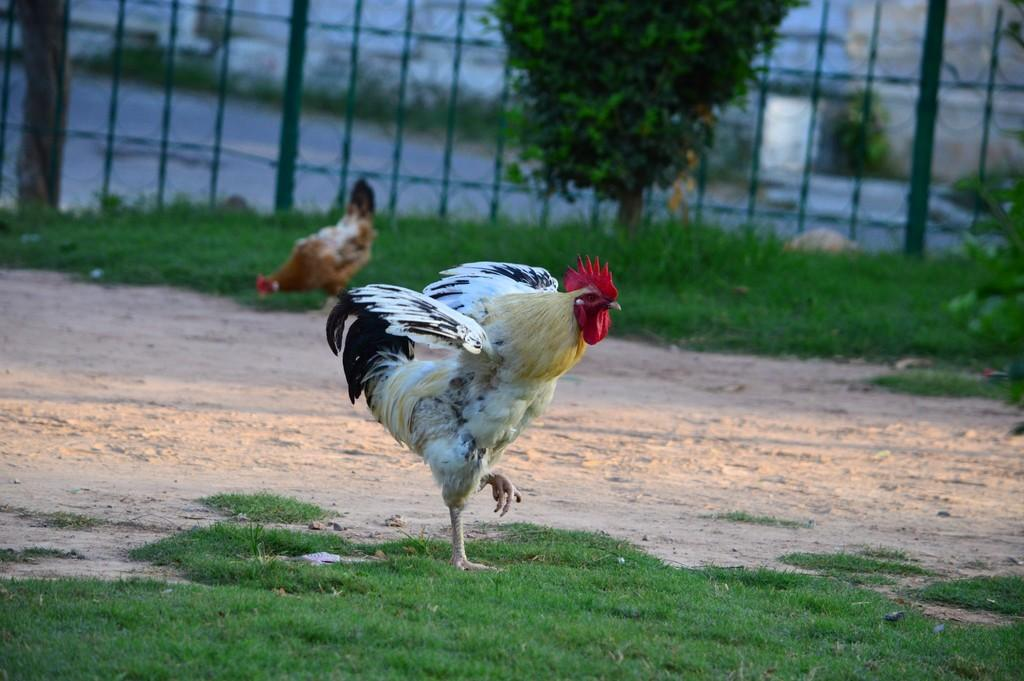What type of vegetation is present in the image? There is grass in the image. What structure can be seen in the image? There is a fence in the image. Are there any plants visible in the image? Yes, there is a plant in the image. What type of animals are present in the image? There are hens in the image. What can be seen in the background of the image? There are buildings in the background of the image. What type of noise can be heard coming from the hens in the image? There is no sound present in the image, so it is not possible to determine what noise might be heard. Is there any indication of expansion or growth in the image? The image does not show any signs of expansion or growth; it only depicts the current state of the scene. 